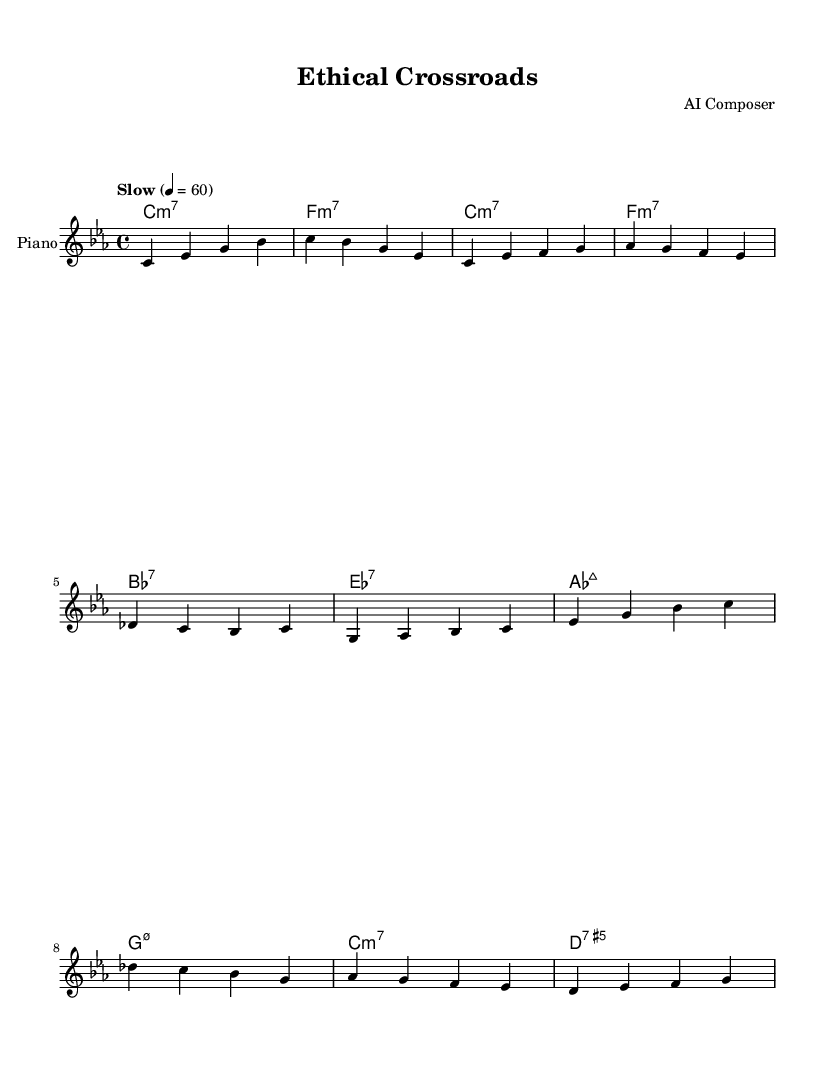What is the key signature of this music? The key signature is C minor, which includes three flats (B♭, E♭, A♭). The first clef indicator shows the key signature, and the following music notes align with this signature.
Answer: C minor What is the time signature of this music? The time signature is indicated at the beginning of the score and is represented as 4/4, which means there are four beats in each measure and the quarter note gets one beat.
Answer: 4/4 What is the tempo marking of this piece? The tempo is notated in the tempo directive as "Slow", with a beat marking of quarter note = 60 beats per minute, indicating a relaxed and measured pacing.
Answer: Slow How many unique chords are used in the chorus? To determine the unique chords in the chorus, we look at the chord section and identify each different chord in that part: A♭ major 7th, G minor 7th, C minor 7th, and D7. There are four different chords used.
Answer: 4 Which measure contains a major 7th chord? The major 7th chord is present in the chorus section of the music, appearing first at the start of the chorus, which corresponds to the A♭ major 7th chord in that measure.
Answer: A♭ major 7th What is the last chord shown in this piece? The last chord is found at the end of the score, where the measure notation shows D7, indicating a dominant seventh chord that resolves the piece.
Answer: D7 